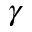Convert formula to latex. <formula><loc_0><loc_0><loc_500><loc_500>\gamma</formula> 